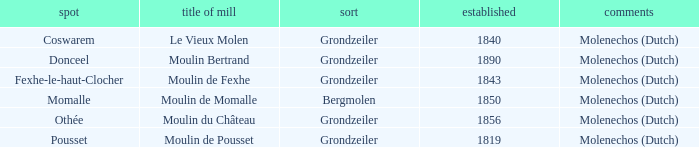What is the Name of the Grondzeiler Mill? Le Vieux Molen, Moulin Bertrand, Moulin de Fexhe, Moulin du Château, Moulin de Pousset. 